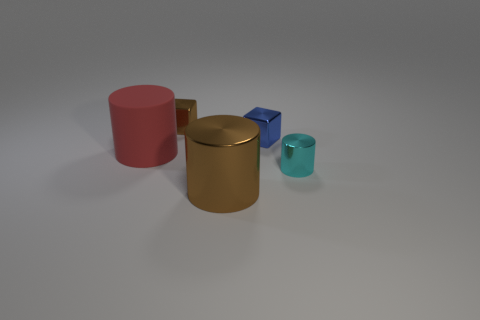There is a small blue metal block; are there any cyan things on the left side of it?
Make the answer very short. No. What number of big metal cylinders are behind the tiny thing that is in front of the matte cylinder?
Provide a succinct answer. 0. There is a cylinder that is the same size as the blue block; what is its material?
Offer a very short reply. Metal. How many other things are the same material as the tiny brown block?
Your response must be concise. 3. There is a red matte thing; what number of small brown blocks are left of it?
Provide a short and direct response. 0. How many cylinders are big objects or big brown objects?
Offer a very short reply. 2. How big is the shiny thing that is both to the left of the blue metallic cube and in front of the blue shiny object?
Ensure brevity in your answer.  Large. What number of other objects are the same color as the large rubber cylinder?
Make the answer very short. 0. Is the big red cylinder made of the same material as the big cylinder in front of the cyan thing?
Keep it short and to the point. No. How many things are small shiny objects that are to the left of the large brown thing or small yellow metal spheres?
Ensure brevity in your answer.  1. 